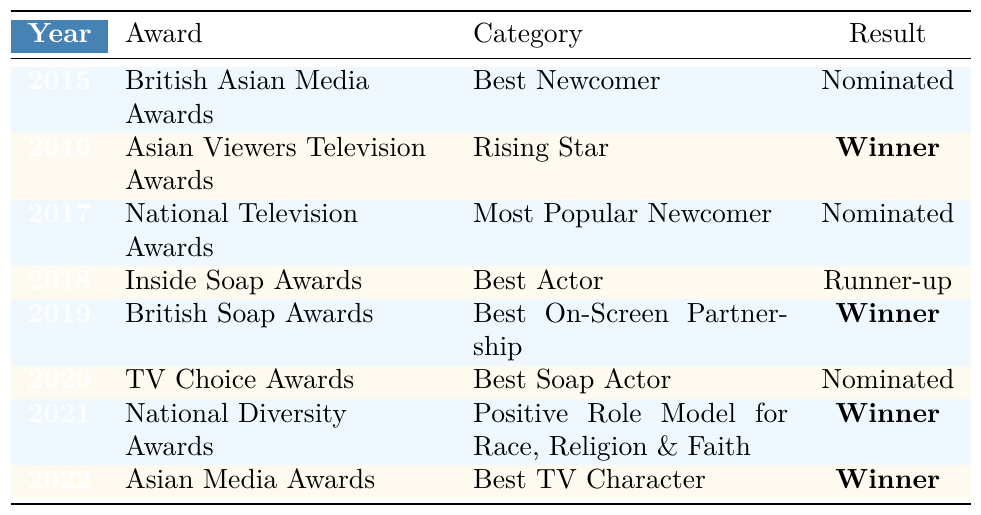What award did Ramzan Miah win in 2016? In 2016, he received the Asian Viewers Television Awards for the category of Rising Star and it shows he was the Winner.
Answer: Winner How many awards has Ramzan Miah been nominated for throughout his career? He was nominated in 2015, 2017, and 2020, which totals three nominations.
Answer: 3 Did Ramzan Miah win any awards in both 2019 and 2021? In 2019, he won the Best On-Screen Partnership at the British Soap Awards, and in 2021, he won the Positive Role Model for Race, Religion & Faith at the National Diversity Awards, confirming he won in both years.
Answer: Yes What was the result of Ramzan Miah's nomination for Best Actor in 2018? The table indicates that in 2018, he was the Runner-up for Best Actor at the Inside Soap Awards.
Answer: Runner-up How many total awards did Ramzan Miah win between 2016 and 2022? He won awards in 2016 (1), 2019 (1), 2021 (1), and 2022 (1), summing up to four wins.
Answer: 4 In which year did Ramzan Miah first receive a nomination? According to the table, his first nomination was in 2015 for the British Asian Media Awards as Best Newcomer.
Answer: 2015 Which award did Ramzan Miah win that recognizes a positive role model? The award recognizing a positive role model was the National Diversity Awards in 2021 for Positive Role Model for Race, Religion & Faith, where he was the Winner.
Answer: National Diversity Awards In how many consecutive years did Ramzan Miah receive nominations from 2015 to 2020? He received nominations in 2015 (1), 2017 (1), and 2020 (1), leading to three nominations spread across the years 2015, 2017, and 2020, hence there are no consecutive years.
Answer: 0 What was Ramzan Miah's overall performance in the awards spanning from 2015 to 2022 based on wins versus nominations? He achieved a total of four wins and three nominations, indicating a strong performance in winning relative to nominations.
Answer: Strong performance Was Ramzan Miah nominated for more categories or did he win more awards overall from 2015 to 2022? He was nominated for three categories and won four awards, showing that he has won more overall than he was nominated for.
Answer: Won more awards than nominated 